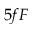<formula> <loc_0><loc_0><loc_500><loc_500>5 f F</formula> 